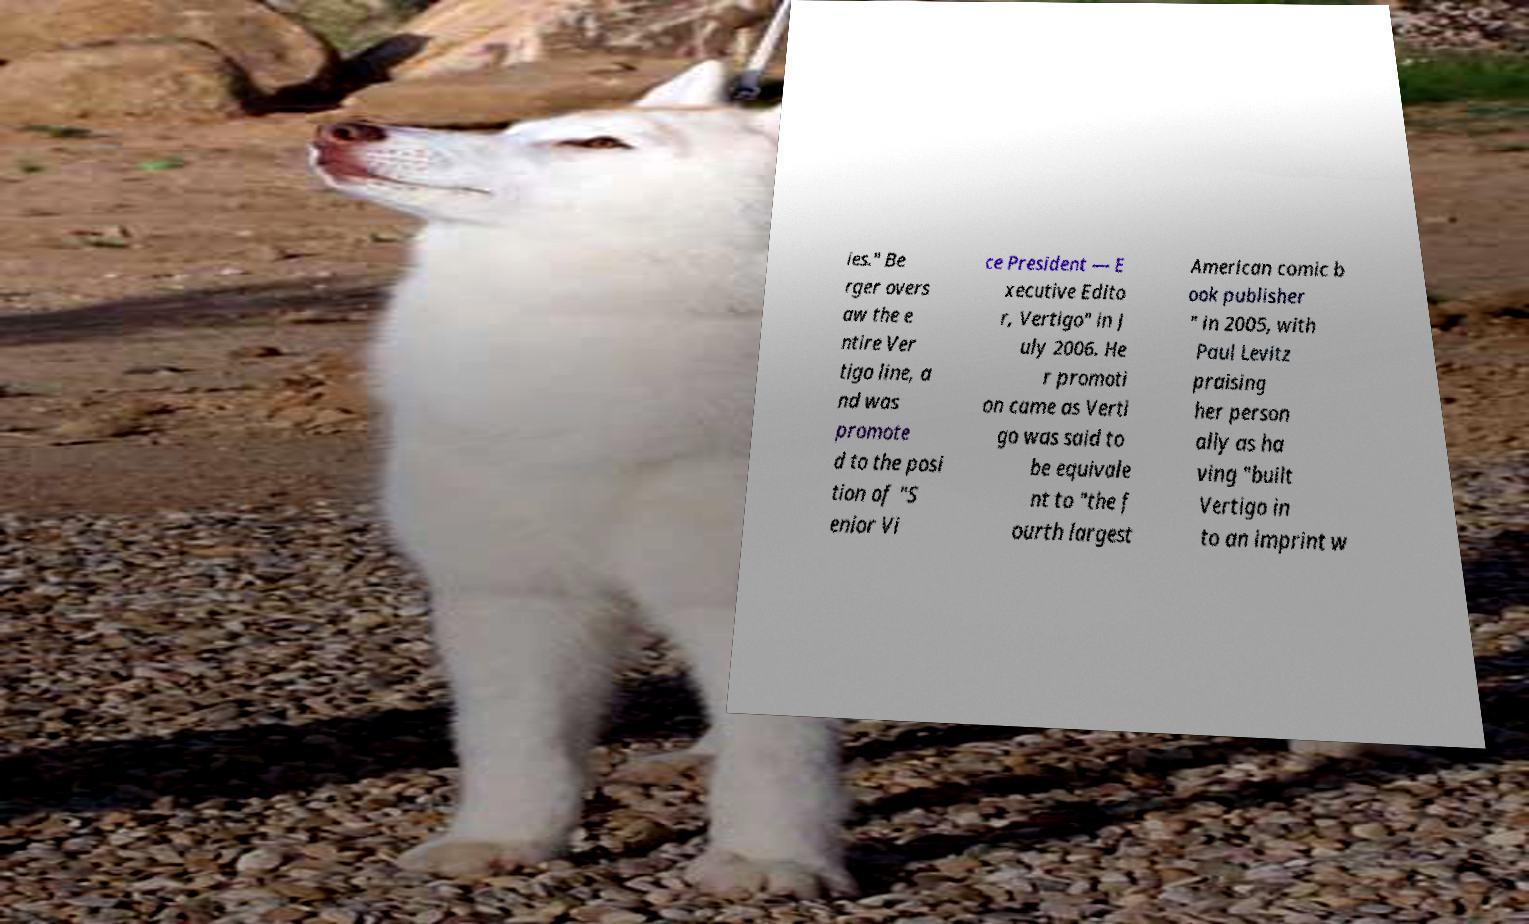There's text embedded in this image that I need extracted. Can you transcribe it verbatim? ies." Be rger overs aw the e ntire Ver tigo line, a nd was promote d to the posi tion of "S enior Vi ce President — E xecutive Edito r, Vertigo" in J uly 2006. He r promoti on came as Verti go was said to be equivale nt to "the f ourth largest American comic b ook publisher " in 2005, with Paul Levitz praising her person ally as ha ving "built Vertigo in to an imprint w 